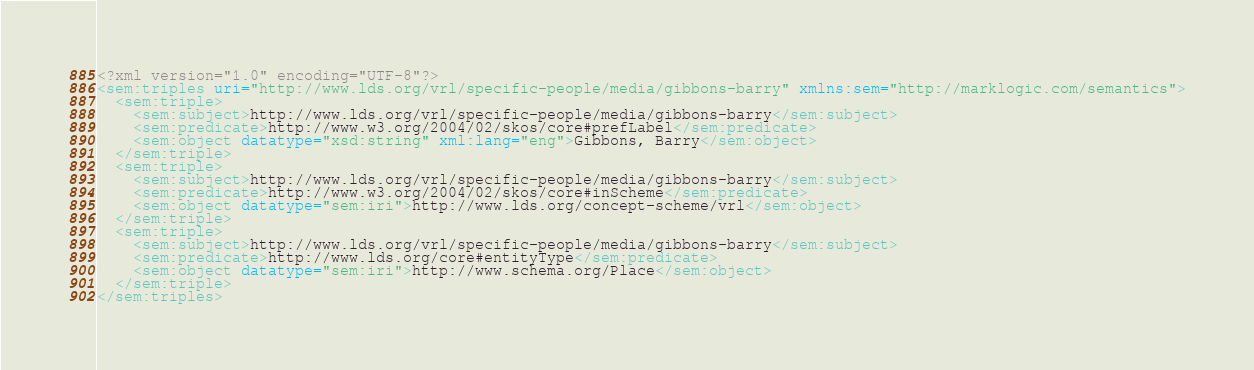Convert code to text. <code><loc_0><loc_0><loc_500><loc_500><_XML_><?xml version="1.0" encoding="UTF-8"?>
<sem:triples uri="http://www.lds.org/vrl/specific-people/media/gibbons-barry" xmlns:sem="http://marklogic.com/semantics">
  <sem:triple>
    <sem:subject>http://www.lds.org/vrl/specific-people/media/gibbons-barry</sem:subject>
    <sem:predicate>http://www.w3.org/2004/02/skos/core#prefLabel</sem:predicate>
    <sem:object datatype="xsd:string" xml:lang="eng">Gibbons, Barry</sem:object>
  </sem:triple>
  <sem:triple>
    <sem:subject>http://www.lds.org/vrl/specific-people/media/gibbons-barry</sem:subject>
    <sem:predicate>http://www.w3.org/2004/02/skos/core#inScheme</sem:predicate>
    <sem:object datatype="sem:iri">http://www.lds.org/concept-scheme/vrl</sem:object>
  </sem:triple>
  <sem:triple>
    <sem:subject>http://www.lds.org/vrl/specific-people/media/gibbons-barry</sem:subject>
    <sem:predicate>http://www.lds.org/core#entityType</sem:predicate>
    <sem:object datatype="sem:iri">http://www.schema.org/Place</sem:object>
  </sem:triple>
</sem:triples>
</code> 